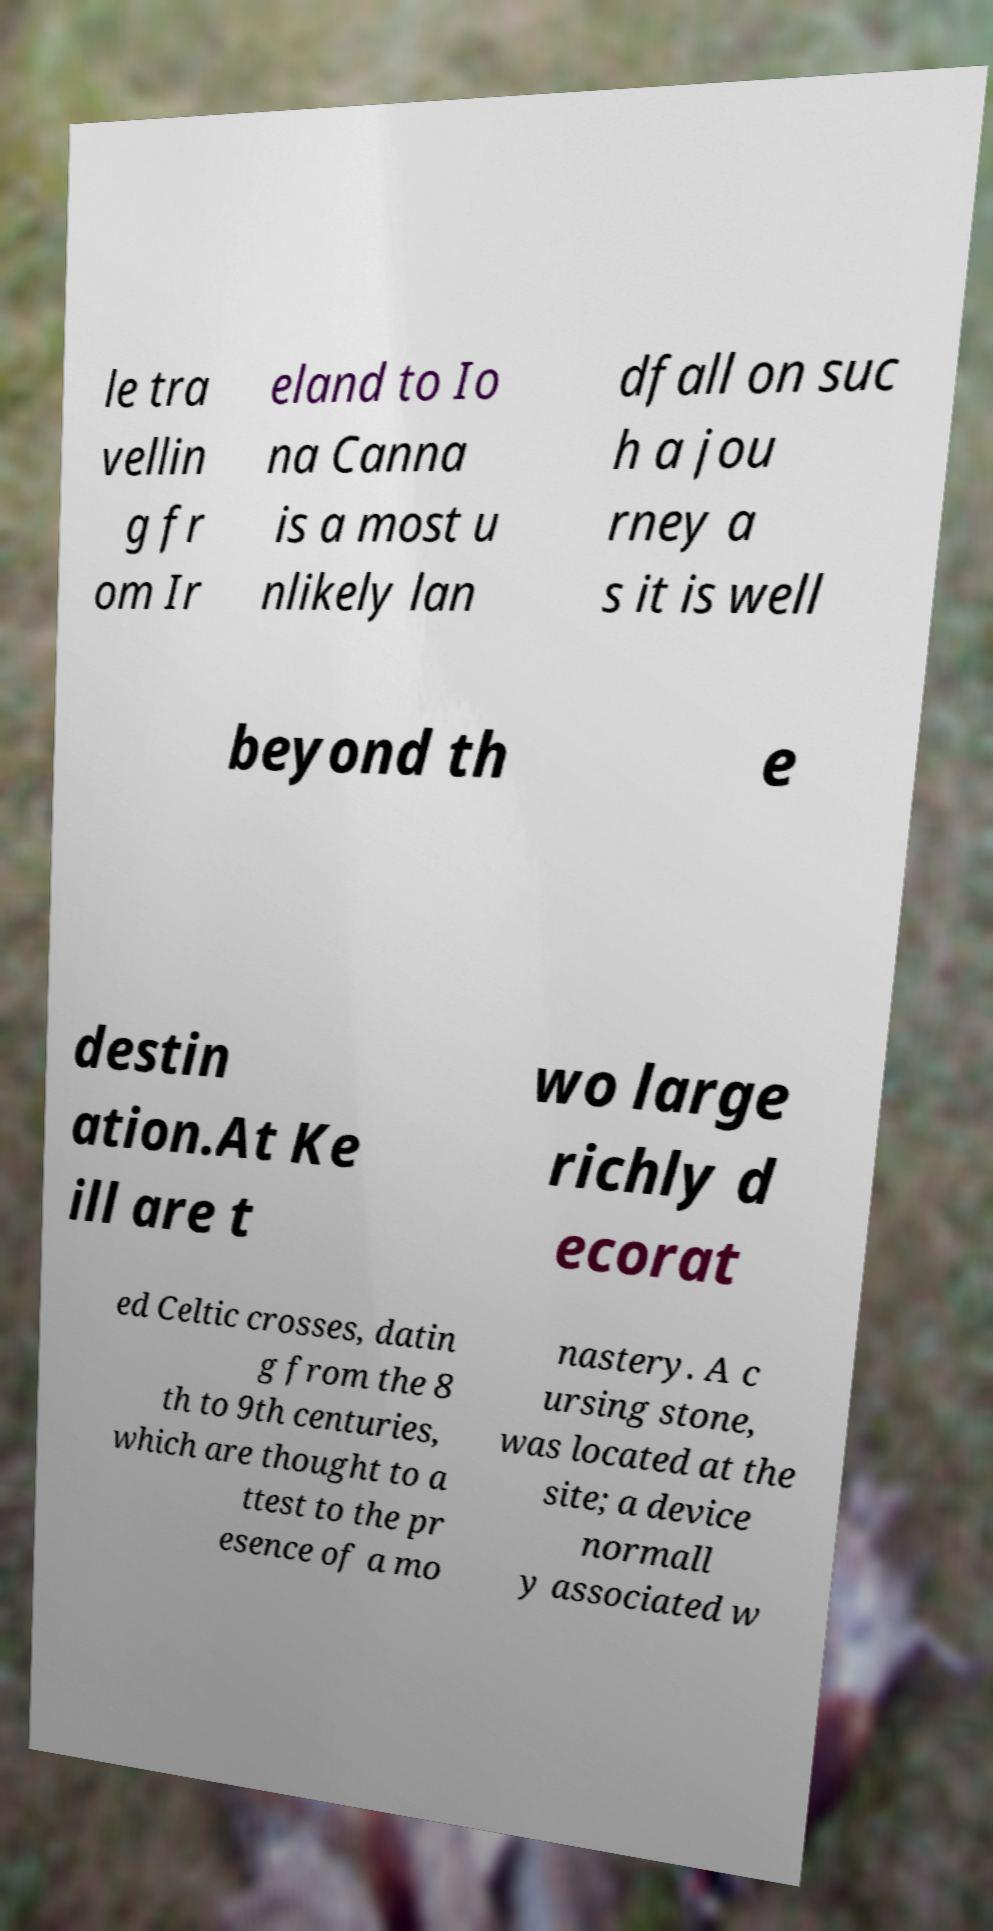Could you assist in decoding the text presented in this image and type it out clearly? le tra vellin g fr om Ir eland to Io na Canna is a most u nlikely lan dfall on suc h a jou rney a s it is well beyond th e destin ation.At Ke ill are t wo large richly d ecorat ed Celtic crosses, datin g from the 8 th to 9th centuries, which are thought to a ttest to the pr esence of a mo nastery. A c ursing stone, was located at the site; a device normall y associated w 